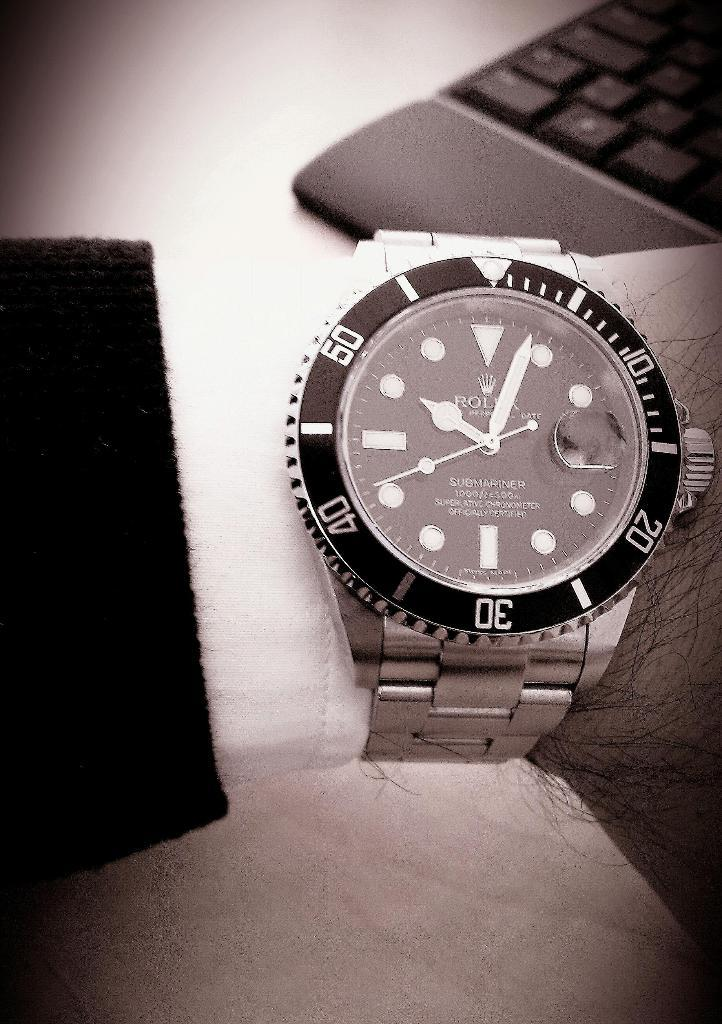Provide a one-sentence caption for the provided image. A Rolex watch called the Submariner is being displayed on someone's wrist. 